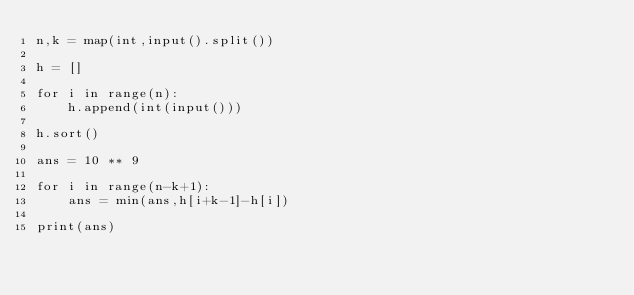Convert code to text. <code><loc_0><loc_0><loc_500><loc_500><_Python_>n,k = map(int,input().split())

h = []

for i in range(n):
    h.append(int(input()))

h.sort()

ans = 10 ** 9

for i in range(n-k+1):
    ans = min(ans,h[i+k-1]-h[i])

print(ans)</code> 